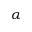<formula> <loc_0><loc_0><loc_500><loc_500>\alpha</formula> 